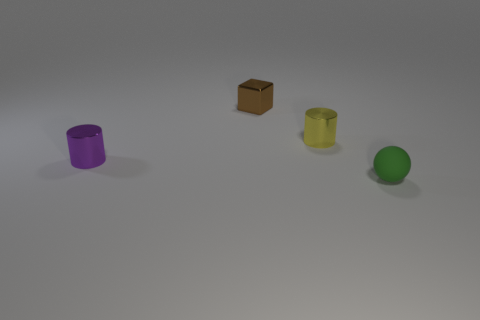There is a tiny yellow shiny cylinder; what number of tiny metallic objects are in front of it?
Provide a succinct answer. 1. What shape is the tiny metallic thing that is both behind the small purple shiny object and in front of the small brown metallic object?
Provide a succinct answer. Cylinder. How many cylinders are small purple objects or small yellow metallic things?
Ensure brevity in your answer.  2. Are there fewer green balls that are on the left side of the small cube than small rubber things?
Offer a terse response. Yes. There is a small metallic thing that is both in front of the shiny block and on the right side of the tiny purple cylinder; what color is it?
Your answer should be very brief. Yellow. How many other things are the same shape as the green object?
Ensure brevity in your answer.  0. Is the number of small metallic blocks on the right side of the yellow object less than the number of yellow objects behind the green ball?
Your answer should be very brief. Yes. Is the material of the tiny block the same as the yellow cylinder right of the brown object?
Offer a terse response. Yes. Are there any other things that are made of the same material as the tiny purple cylinder?
Your answer should be compact. Yes. Are there more small green matte balls than tiny red things?
Offer a very short reply. Yes. 